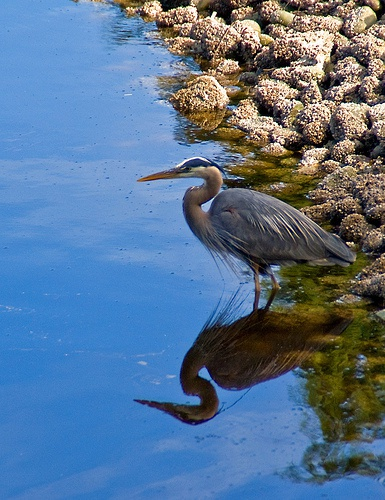Describe the objects in this image and their specific colors. I can see bird in lightblue, gray, black, navy, and darkgray tones and bird in lightblue, black, olive, and navy tones in this image. 